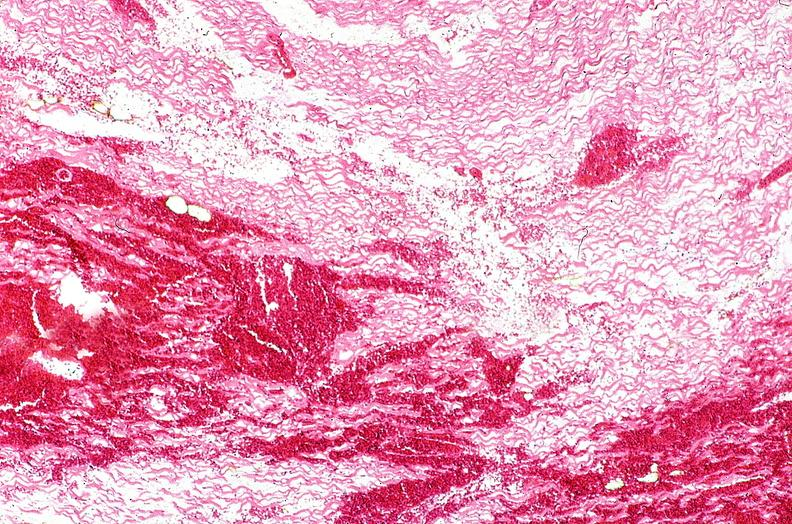s cardiovascular present?
Answer the question using a single word or phrase. Yes 